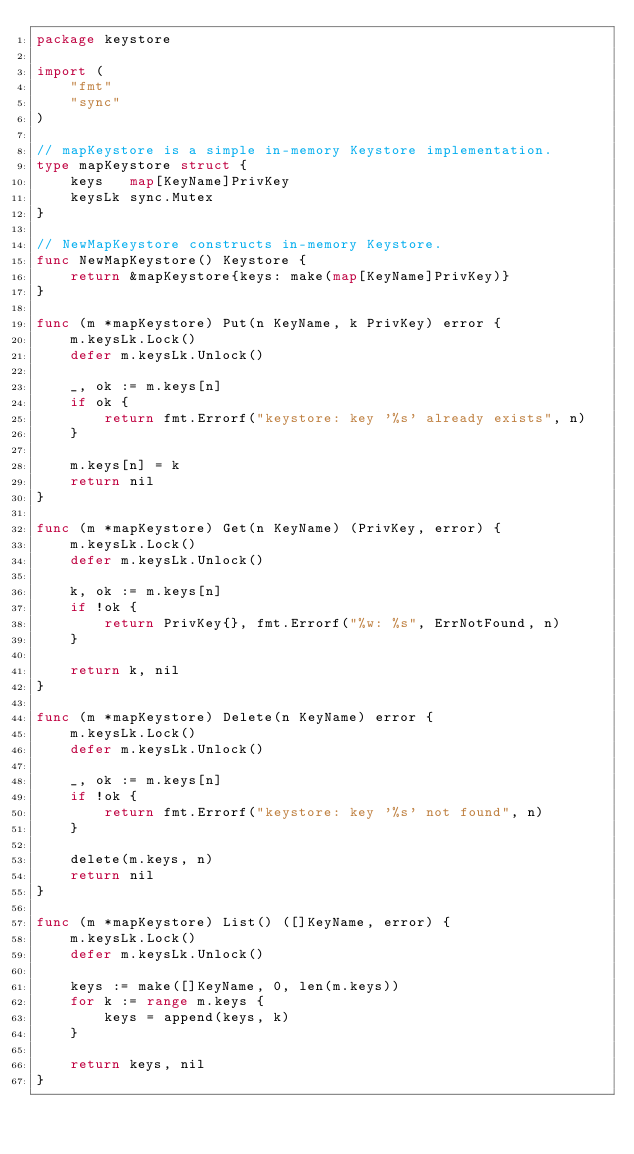Convert code to text. <code><loc_0><loc_0><loc_500><loc_500><_Go_>package keystore

import (
	"fmt"
	"sync"
)

// mapKeystore is a simple in-memory Keystore implementation.
type mapKeystore struct {
	keys   map[KeyName]PrivKey
	keysLk sync.Mutex
}

// NewMapKeystore constructs in-memory Keystore.
func NewMapKeystore() Keystore {
	return &mapKeystore{keys: make(map[KeyName]PrivKey)}
}

func (m *mapKeystore) Put(n KeyName, k PrivKey) error {
	m.keysLk.Lock()
	defer m.keysLk.Unlock()

	_, ok := m.keys[n]
	if ok {
		return fmt.Errorf("keystore: key '%s' already exists", n)
	}

	m.keys[n] = k
	return nil
}

func (m *mapKeystore) Get(n KeyName) (PrivKey, error) {
	m.keysLk.Lock()
	defer m.keysLk.Unlock()

	k, ok := m.keys[n]
	if !ok {
		return PrivKey{}, fmt.Errorf("%w: %s", ErrNotFound, n)
	}

	return k, nil
}

func (m *mapKeystore) Delete(n KeyName) error {
	m.keysLk.Lock()
	defer m.keysLk.Unlock()

	_, ok := m.keys[n]
	if !ok {
		return fmt.Errorf("keystore: key '%s' not found", n)
	}

	delete(m.keys, n)
	return nil
}

func (m *mapKeystore) List() ([]KeyName, error) {
	m.keysLk.Lock()
	defer m.keysLk.Unlock()

	keys := make([]KeyName, 0, len(m.keys))
	for k := range m.keys {
		keys = append(keys, k)
	}

	return keys, nil
}
</code> 